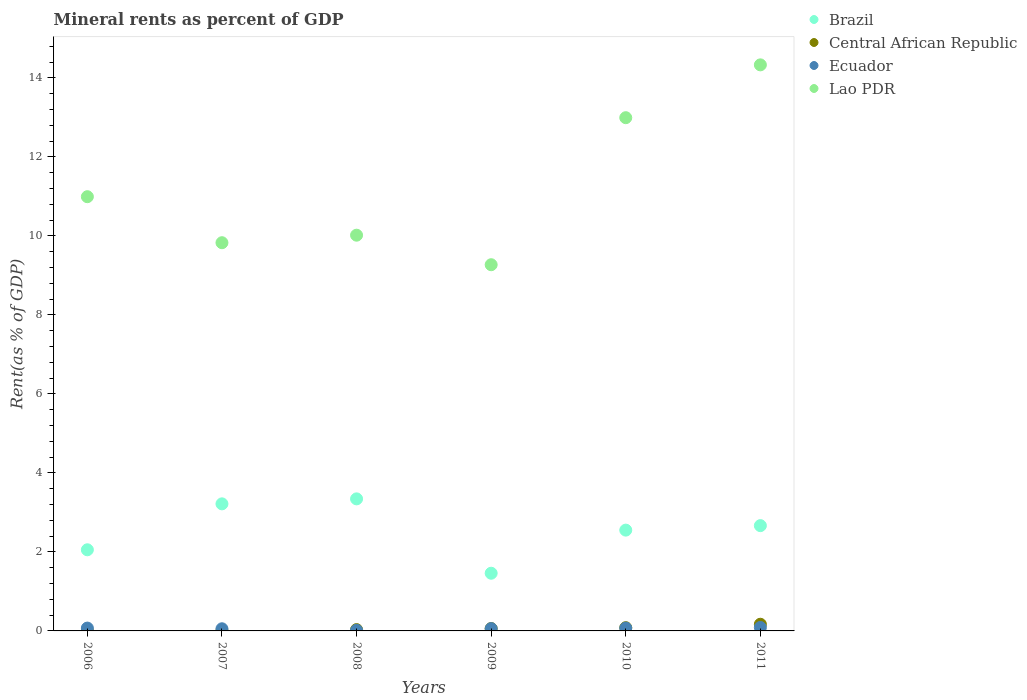What is the mineral rent in Lao PDR in 2010?
Offer a terse response. 12.99. Across all years, what is the maximum mineral rent in Central African Republic?
Offer a very short reply. 0.17. Across all years, what is the minimum mineral rent in Central African Republic?
Provide a short and direct response. 0.01. What is the total mineral rent in Ecuador in the graph?
Make the answer very short. 0.36. What is the difference between the mineral rent in Central African Republic in 2009 and that in 2011?
Provide a succinct answer. -0.11. What is the difference between the mineral rent in Central African Republic in 2006 and the mineral rent in Brazil in 2008?
Ensure brevity in your answer.  -3.34. What is the average mineral rent in Central African Republic per year?
Your answer should be very brief. 0.06. In the year 2011, what is the difference between the mineral rent in Lao PDR and mineral rent in Central African Republic?
Your answer should be compact. 14.16. In how many years, is the mineral rent in Ecuador greater than 12 %?
Ensure brevity in your answer.  0. What is the ratio of the mineral rent in Ecuador in 2007 to that in 2009?
Your response must be concise. 0.93. What is the difference between the highest and the second highest mineral rent in Ecuador?
Make the answer very short. 0.02. What is the difference between the highest and the lowest mineral rent in Central African Republic?
Provide a succinct answer. 0.16. Is the sum of the mineral rent in Central African Republic in 2007 and 2011 greater than the maximum mineral rent in Ecuador across all years?
Make the answer very short. Yes. Is it the case that in every year, the sum of the mineral rent in Ecuador and mineral rent in Central African Republic  is greater than the sum of mineral rent in Lao PDR and mineral rent in Brazil?
Your answer should be compact. No. Are the values on the major ticks of Y-axis written in scientific E-notation?
Offer a terse response. No. Does the graph contain any zero values?
Offer a terse response. No. Does the graph contain grids?
Your response must be concise. No. Where does the legend appear in the graph?
Ensure brevity in your answer.  Top right. What is the title of the graph?
Ensure brevity in your answer.  Mineral rents as percent of GDP. Does "Vietnam" appear as one of the legend labels in the graph?
Offer a terse response. No. What is the label or title of the X-axis?
Give a very brief answer. Years. What is the label or title of the Y-axis?
Provide a succinct answer. Rent(as % of GDP). What is the Rent(as % of GDP) in Brazil in 2006?
Make the answer very short. 2.05. What is the Rent(as % of GDP) of Central African Republic in 2006?
Give a very brief answer. 0.01. What is the Rent(as % of GDP) in Ecuador in 2006?
Keep it short and to the point. 0.07. What is the Rent(as % of GDP) of Lao PDR in 2006?
Keep it short and to the point. 10.99. What is the Rent(as % of GDP) of Brazil in 2007?
Provide a short and direct response. 3.22. What is the Rent(as % of GDP) of Central African Republic in 2007?
Your answer should be compact. 0.01. What is the Rent(as % of GDP) of Ecuador in 2007?
Your answer should be compact. 0.05. What is the Rent(as % of GDP) in Lao PDR in 2007?
Give a very brief answer. 9.83. What is the Rent(as % of GDP) in Brazil in 2008?
Keep it short and to the point. 3.34. What is the Rent(as % of GDP) of Central African Republic in 2008?
Your answer should be very brief. 0.03. What is the Rent(as % of GDP) of Ecuador in 2008?
Your answer should be compact. 0.02. What is the Rent(as % of GDP) of Lao PDR in 2008?
Your response must be concise. 10.02. What is the Rent(as % of GDP) in Brazil in 2009?
Keep it short and to the point. 1.46. What is the Rent(as % of GDP) in Central African Republic in 2009?
Provide a short and direct response. 0.06. What is the Rent(as % of GDP) in Ecuador in 2009?
Make the answer very short. 0.06. What is the Rent(as % of GDP) in Lao PDR in 2009?
Ensure brevity in your answer.  9.27. What is the Rent(as % of GDP) in Brazil in 2010?
Provide a short and direct response. 2.55. What is the Rent(as % of GDP) of Central African Republic in 2010?
Your response must be concise. 0.08. What is the Rent(as % of GDP) in Ecuador in 2010?
Provide a short and direct response. 0.07. What is the Rent(as % of GDP) of Lao PDR in 2010?
Give a very brief answer. 12.99. What is the Rent(as % of GDP) in Brazil in 2011?
Offer a very short reply. 2.66. What is the Rent(as % of GDP) of Central African Republic in 2011?
Your response must be concise. 0.17. What is the Rent(as % of GDP) of Ecuador in 2011?
Your answer should be compact. 0.09. What is the Rent(as % of GDP) of Lao PDR in 2011?
Your response must be concise. 14.33. Across all years, what is the maximum Rent(as % of GDP) of Brazil?
Your response must be concise. 3.34. Across all years, what is the maximum Rent(as % of GDP) of Central African Republic?
Your response must be concise. 0.17. Across all years, what is the maximum Rent(as % of GDP) in Ecuador?
Your answer should be compact. 0.09. Across all years, what is the maximum Rent(as % of GDP) in Lao PDR?
Provide a succinct answer. 14.33. Across all years, what is the minimum Rent(as % of GDP) in Brazil?
Offer a very short reply. 1.46. Across all years, what is the minimum Rent(as % of GDP) of Central African Republic?
Keep it short and to the point. 0.01. Across all years, what is the minimum Rent(as % of GDP) of Ecuador?
Your answer should be very brief. 0.02. Across all years, what is the minimum Rent(as % of GDP) of Lao PDR?
Ensure brevity in your answer.  9.27. What is the total Rent(as % of GDP) in Brazil in the graph?
Make the answer very short. 15.29. What is the total Rent(as % of GDP) in Central African Republic in the graph?
Make the answer very short. 0.36. What is the total Rent(as % of GDP) of Ecuador in the graph?
Your response must be concise. 0.36. What is the total Rent(as % of GDP) of Lao PDR in the graph?
Your answer should be compact. 67.42. What is the difference between the Rent(as % of GDP) in Brazil in 2006 and that in 2007?
Make the answer very short. -1.16. What is the difference between the Rent(as % of GDP) of Central African Republic in 2006 and that in 2007?
Make the answer very short. -0. What is the difference between the Rent(as % of GDP) in Ecuador in 2006 and that in 2007?
Your answer should be compact. 0.02. What is the difference between the Rent(as % of GDP) of Lao PDR in 2006 and that in 2007?
Give a very brief answer. 1.16. What is the difference between the Rent(as % of GDP) in Brazil in 2006 and that in 2008?
Provide a short and direct response. -1.29. What is the difference between the Rent(as % of GDP) of Central African Republic in 2006 and that in 2008?
Offer a terse response. -0.03. What is the difference between the Rent(as % of GDP) of Ecuador in 2006 and that in 2008?
Make the answer very short. 0.05. What is the difference between the Rent(as % of GDP) of Lao PDR in 2006 and that in 2008?
Your response must be concise. 0.97. What is the difference between the Rent(as % of GDP) in Brazil in 2006 and that in 2009?
Give a very brief answer. 0.59. What is the difference between the Rent(as % of GDP) of Central African Republic in 2006 and that in 2009?
Ensure brevity in your answer.  -0.05. What is the difference between the Rent(as % of GDP) in Ecuador in 2006 and that in 2009?
Your response must be concise. 0.01. What is the difference between the Rent(as % of GDP) of Lao PDR in 2006 and that in 2009?
Offer a terse response. 1.72. What is the difference between the Rent(as % of GDP) of Brazil in 2006 and that in 2010?
Give a very brief answer. -0.5. What is the difference between the Rent(as % of GDP) in Central African Republic in 2006 and that in 2010?
Provide a succinct answer. -0.08. What is the difference between the Rent(as % of GDP) in Ecuador in 2006 and that in 2010?
Your response must be concise. -0. What is the difference between the Rent(as % of GDP) of Lao PDR in 2006 and that in 2010?
Ensure brevity in your answer.  -2. What is the difference between the Rent(as % of GDP) in Brazil in 2006 and that in 2011?
Make the answer very short. -0.61. What is the difference between the Rent(as % of GDP) of Central African Republic in 2006 and that in 2011?
Offer a very short reply. -0.16. What is the difference between the Rent(as % of GDP) of Ecuador in 2006 and that in 2011?
Your response must be concise. -0.02. What is the difference between the Rent(as % of GDP) of Lao PDR in 2006 and that in 2011?
Provide a short and direct response. -3.34. What is the difference between the Rent(as % of GDP) in Brazil in 2007 and that in 2008?
Your response must be concise. -0.13. What is the difference between the Rent(as % of GDP) in Central African Republic in 2007 and that in 2008?
Provide a short and direct response. -0.03. What is the difference between the Rent(as % of GDP) in Ecuador in 2007 and that in 2008?
Give a very brief answer. 0.04. What is the difference between the Rent(as % of GDP) in Lao PDR in 2007 and that in 2008?
Keep it short and to the point. -0.19. What is the difference between the Rent(as % of GDP) in Brazil in 2007 and that in 2009?
Your answer should be very brief. 1.76. What is the difference between the Rent(as % of GDP) of Central African Republic in 2007 and that in 2009?
Your response must be concise. -0.05. What is the difference between the Rent(as % of GDP) of Ecuador in 2007 and that in 2009?
Keep it short and to the point. -0. What is the difference between the Rent(as % of GDP) of Lao PDR in 2007 and that in 2009?
Your response must be concise. 0.56. What is the difference between the Rent(as % of GDP) of Brazil in 2007 and that in 2010?
Your response must be concise. 0.67. What is the difference between the Rent(as % of GDP) of Central African Republic in 2007 and that in 2010?
Provide a short and direct response. -0.08. What is the difference between the Rent(as % of GDP) in Ecuador in 2007 and that in 2010?
Ensure brevity in your answer.  -0.02. What is the difference between the Rent(as % of GDP) in Lao PDR in 2007 and that in 2010?
Your response must be concise. -3.16. What is the difference between the Rent(as % of GDP) of Brazil in 2007 and that in 2011?
Your answer should be compact. 0.55. What is the difference between the Rent(as % of GDP) of Central African Republic in 2007 and that in 2011?
Your response must be concise. -0.16. What is the difference between the Rent(as % of GDP) of Ecuador in 2007 and that in 2011?
Ensure brevity in your answer.  -0.03. What is the difference between the Rent(as % of GDP) in Lao PDR in 2007 and that in 2011?
Provide a short and direct response. -4.5. What is the difference between the Rent(as % of GDP) in Brazil in 2008 and that in 2009?
Keep it short and to the point. 1.88. What is the difference between the Rent(as % of GDP) of Central African Republic in 2008 and that in 2009?
Ensure brevity in your answer.  -0.03. What is the difference between the Rent(as % of GDP) of Ecuador in 2008 and that in 2009?
Provide a succinct answer. -0.04. What is the difference between the Rent(as % of GDP) in Lao PDR in 2008 and that in 2009?
Provide a succinct answer. 0.75. What is the difference between the Rent(as % of GDP) in Brazil in 2008 and that in 2010?
Offer a very short reply. 0.79. What is the difference between the Rent(as % of GDP) in Central African Republic in 2008 and that in 2010?
Your answer should be very brief. -0.05. What is the difference between the Rent(as % of GDP) of Ecuador in 2008 and that in 2010?
Make the answer very short. -0.05. What is the difference between the Rent(as % of GDP) of Lao PDR in 2008 and that in 2010?
Provide a succinct answer. -2.97. What is the difference between the Rent(as % of GDP) of Brazil in 2008 and that in 2011?
Offer a terse response. 0.68. What is the difference between the Rent(as % of GDP) in Central African Republic in 2008 and that in 2011?
Offer a very short reply. -0.14. What is the difference between the Rent(as % of GDP) of Ecuador in 2008 and that in 2011?
Keep it short and to the point. -0.07. What is the difference between the Rent(as % of GDP) in Lao PDR in 2008 and that in 2011?
Give a very brief answer. -4.31. What is the difference between the Rent(as % of GDP) in Brazil in 2009 and that in 2010?
Your answer should be compact. -1.09. What is the difference between the Rent(as % of GDP) of Central African Republic in 2009 and that in 2010?
Offer a terse response. -0.02. What is the difference between the Rent(as % of GDP) in Ecuador in 2009 and that in 2010?
Keep it short and to the point. -0.01. What is the difference between the Rent(as % of GDP) in Lao PDR in 2009 and that in 2010?
Provide a succinct answer. -3.72. What is the difference between the Rent(as % of GDP) of Brazil in 2009 and that in 2011?
Ensure brevity in your answer.  -1.2. What is the difference between the Rent(as % of GDP) in Central African Republic in 2009 and that in 2011?
Offer a terse response. -0.11. What is the difference between the Rent(as % of GDP) in Ecuador in 2009 and that in 2011?
Your answer should be compact. -0.03. What is the difference between the Rent(as % of GDP) of Lao PDR in 2009 and that in 2011?
Your response must be concise. -5.06. What is the difference between the Rent(as % of GDP) in Brazil in 2010 and that in 2011?
Your response must be concise. -0.11. What is the difference between the Rent(as % of GDP) in Central African Republic in 2010 and that in 2011?
Provide a succinct answer. -0.09. What is the difference between the Rent(as % of GDP) in Ecuador in 2010 and that in 2011?
Your answer should be compact. -0.02. What is the difference between the Rent(as % of GDP) in Lao PDR in 2010 and that in 2011?
Give a very brief answer. -1.34. What is the difference between the Rent(as % of GDP) in Brazil in 2006 and the Rent(as % of GDP) in Central African Republic in 2007?
Keep it short and to the point. 2.05. What is the difference between the Rent(as % of GDP) of Brazil in 2006 and the Rent(as % of GDP) of Ecuador in 2007?
Offer a very short reply. 2. What is the difference between the Rent(as % of GDP) in Brazil in 2006 and the Rent(as % of GDP) in Lao PDR in 2007?
Offer a very short reply. -7.77. What is the difference between the Rent(as % of GDP) in Central African Republic in 2006 and the Rent(as % of GDP) in Ecuador in 2007?
Offer a terse response. -0.05. What is the difference between the Rent(as % of GDP) in Central African Republic in 2006 and the Rent(as % of GDP) in Lao PDR in 2007?
Your answer should be very brief. -9.82. What is the difference between the Rent(as % of GDP) in Ecuador in 2006 and the Rent(as % of GDP) in Lao PDR in 2007?
Offer a very short reply. -9.75. What is the difference between the Rent(as % of GDP) of Brazil in 2006 and the Rent(as % of GDP) of Central African Republic in 2008?
Make the answer very short. 2.02. What is the difference between the Rent(as % of GDP) in Brazil in 2006 and the Rent(as % of GDP) in Ecuador in 2008?
Keep it short and to the point. 2.04. What is the difference between the Rent(as % of GDP) of Brazil in 2006 and the Rent(as % of GDP) of Lao PDR in 2008?
Ensure brevity in your answer.  -7.96. What is the difference between the Rent(as % of GDP) of Central African Republic in 2006 and the Rent(as % of GDP) of Ecuador in 2008?
Your answer should be compact. -0.01. What is the difference between the Rent(as % of GDP) of Central African Republic in 2006 and the Rent(as % of GDP) of Lao PDR in 2008?
Provide a short and direct response. -10.01. What is the difference between the Rent(as % of GDP) in Ecuador in 2006 and the Rent(as % of GDP) in Lao PDR in 2008?
Make the answer very short. -9.94. What is the difference between the Rent(as % of GDP) in Brazil in 2006 and the Rent(as % of GDP) in Central African Republic in 2009?
Ensure brevity in your answer.  1.99. What is the difference between the Rent(as % of GDP) in Brazil in 2006 and the Rent(as % of GDP) in Ecuador in 2009?
Your answer should be very brief. 2. What is the difference between the Rent(as % of GDP) in Brazil in 2006 and the Rent(as % of GDP) in Lao PDR in 2009?
Provide a succinct answer. -7.22. What is the difference between the Rent(as % of GDP) in Central African Republic in 2006 and the Rent(as % of GDP) in Ecuador in 2009?
Give a very brief answer. -0.05. What is the difference between the Rent(as % of GDP) of Central African Republic in 2006 and the Rent(as % of GDP) of Lao PDR in 2009?
Your response must be concise. -9.26. What is the difference between the Rent(as % of GDP) of Ecuador in 2006 and the Rent(as % of GDP) of Lao PDR in 2009?
Offer a very short reply. -9.2. What is the difference between the Rent(as % of GDP) in Brazil in 2006 and the Rent(as % of GDP) in Central African Republic in 2010?
Provide a succinct answer. 1.97. What is the difference between the Rent(as % of GDP) in Brazil in 2006 and the Rent(as % of GDP) in Ecuador in 2010?
Offer a very short reply. 1.98. What is the difference between the Rent(as % of GDP) of Brazil in 2006 and the Rent(as % of GDP) of Lao PDR in 2010?
Your answer should be very brief. -10.94. What is the difference between the Rent(as % of GDP) in Central African Republic in 2006 and the Rent(as % of GDP) in Ecuador in 2010?
Make the answer very short. -0.07. What is the difference between the Rent(as % of GDP) of Central African Republic in 2006 and the Rent(as % of GDP) of Lao PDR in 2010?
Your answer should be very brief. -12.99. What is the difference between the Rent(as % of GDP) of Ecuador in 2006 and the Rent(as % of GDP) of Lao PDR in 2010?
Offer a very short reply. -12.92. What is the difference between the Rent(as % of GDP) of Brazil in 2006 and the Rent(as % of GDP) of Central African Republic in 2011?
Ensure brevity in your answer.  1.88. What is the difference between the Rent(as % of GDP) in Brazil in 2006 and the Rent(as % of GDP) in Ecuador in 2011?
Provide a succinct answer. 1.97. What is the difference between the Rent(as % of GDP) in Brazil in 2006 and the Rent(as % of GDP) in Lao PDR in 2011?
Your answer should be compact. -12.27. What is the difference between the Rent(as % of GDP) of Central African Republic in 2006 and the Rent(as % of GDP) of Ecuador in 2011?
Offer a terse response. -0.08. What is the difference between the Rent(as % of GDP) of Central African Republic in 2006 and the Rent(as % of GDP) of Lao PDR in 2011?
Provide a succinct answer. -14.32. What is the difference between the Rent(as % of GDP) in Ecuador in 2006 and the Rent(as % of GDP) in Lao PDR in 2011?
Make the answer very short. -14.26. What is the difference between the Rent(as % of GDP) in Brazil in 2007 and the Rent(as % of GDP) in Central African Republic in 2008?
Give a very brief answer. 3.18. What is the difference between the Rent(as % of GDP) in Brazil in 2007 and the Rent(as % of GDP) in Ecuador in 2008?
Ensure brevity in your answer.  3.2. What is the difference between the Rent(as % of GDP) in Brazil in 2007 and the Rent(as % of GDP) in Lao PDR in 2008?
Make the answer very short. -6.8. What is the difference between the Rent(as % of GDP) of Central African Republic in 2007 and the Rent(as % of GDP) of Ecuador in 2008?
Ensure brevity in your answer.  -0.01. What is the difference between the Rent(as % of GDP) in Central African Republic in 2007 and the Rent(as % of GDP) in Lao PDR in 2008?
Give a very brief answer. -10.01. What is the difference between the Rent(as % of GDP) of Ecuador in 2007 and the Rent(as % of GDP) of Lao PDR in 2008?
Ensure brevity in your answer.  -9.96. What is the difference between the Rent(as % of GDP) of Brazil in 2007 and the Rent(as % of GDP) of Central African Republic in 2009?
Make the answer very short. 3.16. What is the difference between the Rent(as % of GDP) of Brazil in 2007 and the Rent(as % of GDP) of Ecuador in 2009?
Offer a very short reply. 3.16. What is the difference between the Rent(as % of GDP) of Brazil in 2007 and the Rent(as % of GDP) of Lao PDR in 2009?
Make the answer very short. -6.05. What is the difference between the Rent(as % of GDP) in Central African Republic in 2007 and the Rent(as % of GDP) in Ecuador in 2009?
Make the answer very short. -0.05. What is the difference between the Rent(as % of GDP) in Central African Republic in 2007 and the Rent(as % of GDP) in Lao PDR in 2009?
Your answer should be very brief. -9.26. What is the difference between the Rent(as % of GDP) of Ecuador in 2007 and the Rent(as % of GDP) of Lao PDR in 2009?
Ensure brevity in your answer.  -9.21. What is the difference between the Rent(as % of GDP) in Brazil in 2007 and the Rent(as % of GDP) in Central African Republic in 2010?
Provide a short and direct response. 3.13. What is the difference between the Rent(as % of GDP) of Brazil in 2007 and the Rent(as % of GDP) of Ecuador in 2010?
Your answer should be very brief. 3.14. What is the difference between the Rent(as % of GDP) in Brazil in 2007 and the Rent(as % of GDP) in Lao PDR in 2010?
Your answer should be very brief. -9.77. What is the difference between the Rent(as % of GDP) of Central African Republic in 2007 and the Rent(as % of GDP) of Ecuador in 2010?
Your answer should be compact. -0.07. What is the difference between the Rent(as % of GDP) of Central African Republic in 2007 and the Rent(as % of GDP) of Lao PDR in 2010?
Keep it short and to the point. -12.98. What is the difference between the Rent(as % of GDP) of Ecuador in 2007 and the Rent(as % of GDP) of Lao PDR in 2010?
Ensure brevity in your answer.  -12.94. What is the difference between the Rent(as % of GDP) of Brazil in 2007 and the Rent(as % of GDP) of Central African Republic in 2011?
Provide a short and direct response. 3.05. What is the difference between the Rent(as % of GDP) of Brazil in 2007 and the Rent(as % of GDP) of Ecuador in 2011?
Your answer should be very brief. 3.13. What is the difference between the Rent(as % of GDP) of Brazil in 2007 and the Rent(as % of GDP) of Lao PDR in 2011?
Make the answer very short. -11.11. What is the difference between the Rent(as % of GDP) of Central African Republic in 2007 and the Rent(as % of GDP) of Ecuador in 2011?
Offer a very short reply. -0.08. What is the difference between the Rent(as % of GDP) in Central African Republic in 2007 and the Rent(as % of GDP) in Lao PDR in 2011?
Your answer should be compact. -14.32. What is the difference between the Rent(as % of GDP) in Ecuador in 2007 and the Rent(as % of GDP) in Lao PDR in 2011?
Offer a very short reply. -14.27. What is the difference between the Rent(as % of GDP) in Brazil in 2008 and the Rent(as % of GDP) in Central African Republic in 2009?
Ensure brevity in your answer.  3.28. What is the difference between the Rent(as % of GDP) of Brazil in 2008 and the Rent(as % of GDP) of Ecuador in 2009?
Make the answer very short. 3.28. What is the difference between the Rent(as % of GDP) of Brazil in 2008 and the Rent(as % of GDP) of Lao PDR in 2009?
Your answer should be very brief. -5.93. What is the difference between the Rent(as % of GDP) of Central African Republic in 2008 and the Rent(as % of GDP) of Ecuador in 2009?
Your answer should be compact. -0.02. What is the difference between the Rent(as % of GDP) of Central African Republic in 2008 and the Rent(as % of GDP) of Lao PDR in 2009?
Your answer should be very brief. -9.24. What is the difference between the Rent(as % of GDP) of Ecuador in 2008 and the Rent(as % of GDP) of Lao PDR in 2009?
Your answer should be compact. -9.25. What is the difference between the Rent(as % of GDP) of Brazil in 2008 and the Rent(as % of GDP) of Central African Republic in 2010?
Offer a terse response. 3.26. What is the difference between the Rent(as % of GDP) in Brazil in 2008 and the Rent(as % of GDP) in Ecuador in 2010?
Keep it short and to the point. 3.27. What is the difference between the Rent(as % of GDP) of Brazil in 2008 and the Rent(as % of GDP) of Lao PDR in 2010?
Your answer should be very brief. -9.65. What is the difference between the Rent(as % of GDP) of Central African Republic in 2008 and the Rent(as % of GDP) of Ecuador in 2010?
Provide a short and direct response. -0.04. What is the difference between the Rent(as % of GDP) of Central African Republic in 2008 and the Rent(as % of GDP) of Lao PDR in 2010?
Provide a succinct answer. -12.96. What is the difference between the Rent(as % of GDP) of Ecuador in 2008 and the Rent(as % of GDP) of Lao PDR in 2010?
Keep it short and to the point. -12.97. What is the difference between the Rent(as % of GDP) of Brazil in 2008 and the Rent(as % of GDP) of Central African Republic in 2011?
Your answer should be very brief. 3.17. What is the difference between the Rent(as % of GDP) of Brazil in 2008 and the Rent(as % of GDP) of Ecuador in 2011?
Keep it short and to the point. 3.25. What is the difference between the Rent(as % of GDP) of Brazil in 2008 and the Rent(as % of GDP) of Lao PDR in 2011?
Keep it short and to the point. -10.99. What is the difference between the Rent(as % of GDP) in Central African Republic in 2008 and the Rent(as % of GDP) in Ecuador in 2011?
Offer a very short reply. -0.05. What is the difference between the Rent(as % of GDP) of Central African Republic in 2008 and the Rent(as % of GDP) of Lao PDR in 2011?
Your answer should be very brief. -14.29. What is the difference between the Rent(as % of GDP) in Ecuador in 2008 and the Rent(as % of GDP) in Lao PDR in 2011?
Offer a terse response. -14.31. What is the difference between the Rent(as % of GDP) in Brazil in 2009 and the Rent(as % of GDP) in Central African Republic in 2010?
Keep it short and to the point. 1.38. What is the difference between the Rent(as % of GDP) in Brazil in 2009 and the Rent(as % of GDP) in Ecuador in 2010?
Your response must be concise. 1.39. What is the difference between the Rent(as % of GDP) of Brazil in 2009 and the Rent(as % of GDP) of Lao PDR in 2010?
Make the answer very short. -11.53. What is the difference between the Rent(as % of GDP) in Central African Republic in 2009 and the Rent(as % of GDP) in Ecuador in 2010?
Your answer should be very brief. -0.01. What is the difference between the Rent(as % of GDP) in Central African Republic in 2009 and the Rent(as % of GDP) in Lao PDR in 2010?
Ensure brevity in your answer.  -12.93. What is the difference between the Rent(as % of GDP) of Ecuador in 2009 and the Rent(as % of GDP) of Lao PDR in 2010?
Offer a terse response. -12.93. What is the difference between the Rent(as % of GDP) of Brazil in 2009 and the Rent(as % of GDP) of Central African Republic in 2011?
Ensure brevity in your answer.  1.29. What is the difference between the Rent(as % of GDP) of Brazil in 2009 and the Rent(as % of GDP) of Ecuador in 2011?
Give a very brief answer. 1.37. What is the difference between the Rent(as % of GDP) in Brazil in 2009 and the Rent(as % of GDP) in Lao PDR in 2011?
Your answer should be very brief. -12.87. What is the difference between the Rent(as % of GDP) in Central African Republic in 2009 and the Rent(as % of GDP) in Ecuador in 2011?
Your answer should be compact. -0.03. What is the difference between the Rent(as % of GDP) in Central African Republic in 2009 and the Rent(as % of GDP) in Lao PDR in 2011?
Keep it short and to the point. -14.27. What is the difference between the Rent(as % of GDP) in Ecuador in 2009 and the Rent(as % of GDP) in Lao PDR in 2011?
Provide a short and direct response. -14.27. What is the difference between the Rent(as % of GDP) in Brazil in 2010 and the Rent(as % of GDP) in Central African Republic in 2011?
Your answer should be very brief. 2.38. What is the difference between the Rent(as % of GDP) in Brazil in 2010 and the Rent(as % of GDP) in Ecuador in 2011?
Make the answer very short. 2.46. What is the difference between the Rent(as % of GDP) in Brazil in 2010 and the Rent(as % of GDP) in Lao PDR in 2011?
Ensure brevity in your answer.  -11.78. What is the difference between the Rent(as % of GDP) of Central African Republic in 2010 and the Rent(as % of GDP) of Ecuador in 2011?
Provide a succinct answer. -0.01. What is the difference between the Rent(as % of GDP) in Central African Republic in 2010 and the Rent(as % of GDP) in Lao PDR in 2011?
Provide a short and direct response. -14.25. What is the difference between the Rent(as % of GDP) of Ecuador in 2010 and the Rent(as % of GDP) of Lao PDR in 2011?
Keep it short and to the point. -14.26. What is the average Rent(as % of GDP) in Brazil per year?
Keep it short and to the point. 2.55. What is the average Rent(as % of GDP) of Central African Republic per year?
Provide a short and direct response. 0.06. What is the average Rent(as % of GDP) of Ecuador per year?
Your response must be concise. 0.06. What is the average Rent(as % of GDP) of Lao PDR per year?
Keep it short and to the point. 11.24. In the year 2006, what is the difference between the Rent(as % of GDP) of Brazil and Rent(as % of GDP) of Central African Republic?
Give a very brief answer. 2.05. In the year 2006, what is the difference between the Rent(as % of GDP) of Brazil and Rent(as % of GDP) of Ecuador?
Your answer should be very brief. 1.98. In the year 2006, what is the difference between the Rent(as % of GDP) in Brazil and Rent(as % of GDP) in Lao PDR?
Give a very brief answer. -8.94. In the year 2006, what is the difference between the Rent(as % of GDP) of Central African Republic and Rent(as % of GDP) of Ecuador?
Make the answer very short. -0.07. In the year 2006, what is the difference between the Rent(as % of GDP) of Central African Republic and Rent(as % of GDP) of Lao PDR?
Provide a short and direct response. -10.99. In the year 2006, what is the difference between the Rent(as % of GDP) in Ecuador and Rent(as % of GDP) in Lao PDR?
Ensure brevity in your answer.  -10.92. In the year 2007, what is the difference between the Rent(as % of GDP) of Brazil and Rent(as % of GDP) of Central African Republic?
Make the answer very short. 3.21. In the year 2007, what is the difference between the Rent(as % of GDP) of Brazil and Rent(as % of GDP) of Ecuador?
Your response must be concise. 3.16. In the year 2007, what is the difference between the Rent(as % of GDP) of Brazil and Rent(as % of GDP) of Lao PDR?
Your answer should be very brief. -6.61. In the year 2007, what is the difference between the Rent(as % of GDP) in Central African Republic and Rent(as % of GDP) in Ecuador?
Offer a very short reply. -0.05. In the year 2007, what is the difference between the Rent(as % of GDP) in Central African Republic and Rent(as % of GDP) in Lao PDR?
Your answer should be very brief. -9.82. In the year 2007, what is the difference between the Rent(as % of GDP) in Ecuador and Rent(as % of GDP) in Lao PDR?
Offer a terse response. -9.77. In the year 2008, what is the difference between the Rent(as % of GDP) of Brazil and Rent(as % of GDP) of Central African Republic?
Provide a short and direct response. 3.31. In the year 2008, what is the difference between the Rent(as % of GDP) in Brazil and Rent(as % of GDP) in Ecuador?
Give a very brief answer. 3.33. In the year 2008, what is the difference between the Rent(as % of GDP) of Brazil and Rent(as % of GDP) of Lao PDR?
Keep it short and to the point. -6.67. In the year 2008, what is the difference between the Rent(as % of GDP) of Central African Republic and Rent(as % of GDP) of Ecuador?
Offer a terse response. 0.02. In the year 2008, what is the difference between the Rent(as % of GDP) of Central African Republic and Rent(as % of GDP) of Lao PDR?
Your answer should be very brief. -9.98. In the year 2008, what is the difference between the Rent(as % of GDP) of Ecuador and Rent(as % of GDP) of Lao PDR?
Keep it short and to the point. -10. In the year 2009, what is the difference between the Rent(as % of GDP) of Brazil and Rent(as % of GDP) of Central African Republic?
Provide a short and direct response. 1.4. In the year 2009, what is the difference between the Rent(as % of GDP) of Brazil and Rent(as % of GDP) of Ecuador?
Provide a succinct answer. 1.4. In the year 2009, what is the difference between the Rent(as % of GDP) in Brazil and Rent(as % of GDP) in Lao PDR?
Keep it short and to the point. -7.81. In the year 2009, what is the difference between the Rent(as % of GDP) of Central African Republic and Rent(as % of GDP) of Ecuador?
Your response must be concise. 0. In the year 2009, what is the difference between the Rent(as % of GDP) in Central African Republic and Rent(as % of GDP) in Lao PDR?
Keep it short and to the point. -9.21. In the year 2009, what is the difference between the Rent(as % of GDP) of Ecuador and Rent(as % of GDP) of Lao PDR?
Your answer should be compact. -9.21. In the year 2010, what is the difference between the Rent(as % of GDP) in Brazil and Rent(as % of GDP) in Central African Republic?
Your answer should be compact. 2.47. In the year 2010, what is the difference between the Rent(as % of GDP) of Brazil and Rent(as % of GDP) of Ecuador?
Offer a very short reply. 2.48. In the year 2010, what is the difference between the Rent(as % of GDP) of Brazil and Rent(as % of GDP) of Lao PDR?
Your response must be concise. -10.44. In the year 2010, what is the difference between the Rent(as % of GDP) of Central African Republic and Rent(as % of GDP) of Ecuador?
Ensure brevity in your answer.  0.01. In the year 2010, what is the difference between the Rent(as % of GDP) of Central African Republic and Rent(as % of GDP) of Lao PDR?
Give a very brief answer. -12.91. In the year 2010, what is the difference between the Rent(as % of GDP) of Ecuador and Rent(as % of GDP) of Lao PDR?
Offer a very short reply. -12.92. In the year 2011, what is the difference between the Rent(as % of GDP) in Brazil and Rent(as % of GDP) in Central African Republic?
Your answer should be compact. 2.5. In the year 2011, what is the difference between the Rent(as % of GDP) of Brazil and Rent(as % of GDP) of Ecuador?
Give a very brief answer. 2.58. In the year 2011, what is the difference between the Rent(as % of GDP) of Brazil and Rent(as % of GDP) of Lao PDR?
Keep it short and to the point. -11.66. In the year 2011, what is the difference between the Rent(as % of GDP) in Central African Republic and Rent(as % of GDP) in Ecuador?
Make the answer very short. 0.08. In the year 2011, what is the difference between the Rent(as % of GDP) in Central African Republic and Rent(as % of GDP) in Lao PDR?
Offer a terse response. -14.16. In the year 2011, what is the difference between the Rent(as % of GDP) in Ecuador and Rent(as % of GDP) in Lao PDR?
Offer a terse response. -14.24. What is the ratio of the Rent(as % of GDP) of Brazil in 2006 to that in 2007?
Provide a succinct answer. 0.64. What is the ratio of the Rent(as % of GDP) in Central African Republic in 2006 to that in 2007?
Keep it short and to the point. 0.91. What is the ratio of the Rent(as % of GDP) in Ecuador in 2006 to that in 2007?
Offer a very short reply. 1.32. What is the ratio of the Rent(as % of GDP) in Lao PDR in 2006 to that in 2007?
Make the answer very short. 1.12. What is the ratio of the Rent(as % of GDP) of Brazil in 2006 to that in 2008?
Your answer should be very brief. 0.61. What is the ratio of the Rent(as % of GDP) of Central African Republic in 2006 to that in 2008?
Provide a succinct answer. 0.17. What is the ratio of the Rent(as % of GDP) of Ecuador in 2006 to that in 2008?
Make the answer very short. 4.19. What is the ratio of the Rent(as % of GDP) in Lao PDR in 2006 to that in 2008?
Your response must be concise. 1.1. What is the ratio of the Rent(as % of GDP) of Brazil in 2006 to that in 2009?
Make the answer very short. 1.41. What is the ratio of the Rent(as % of GDP) of Central African Republic in 2006 to that in 2009?
Give a very brief answer. 0.1. What is the ratio of the Rent(as % of GDP) in Ecuador in 2006 to that in 2009?
Your response must be concise. 1.23. What is the ratio of the Rent(as % of GDP) of Lao PDR in 2006 to that in 2009?
Your answer should be compact. 1.19. What is the ratio of the Rent(as % of GDP) of Brazil in 2006 to that in 2010?
Offer a terse response. 0.8. What is the ratio of the Rent(as % of GDP) in Central African Republic in 2006 to that in 2010?
Give a very brief answer. 0.07. What is the ratio of the Rent(as % of GDP) of Ecuador in 2006 to that in 2010?
Your response must be concise. 1. What is the ratio of the Rent(as % of GDP) of Lao PDR in 2006 to that in 2010?
Provide a succinct answer. 0.85. What is the ratio of the Rent(as % of GDP) of Brazil in 2006 to that in 2011?
Give a very brief answer. 0.77. What is the ratio of the Rent(as % of GDP) of Central African Republic in 2006 to that in 2011?
Keep it short and to the point. 0.03. What is the ratio of the Rent(as % of GDP) in Ecuador in 2006 to that in 2011?
Offer a very short reply. 0.82. What is the ratio of the Rent(as % of GDP) of Lao PDR in 2006 to that in 2011?
Your answer should be very brief. 0.77. What is the ratio of the Rent(as % of GDP) in Brazil in 2007 to that in 2008?
Offer a very short reply. 0.96. What is the ratio of the Rent(as % of GDP) of Central African Republic in 2007 to that in 2008?
Offer a terse response. 0.19. What is the ratio of the Rent(as % of GDP) in Ecuador in 2007 to that in 2008?
Offer a terse response. 3.16. What is the ratio of the Rent(as % of GDP) of Lao PDR in 2007 to that in 2008?
Keep it short and to the point. 0.98. What is the ratio of the Rent(as % of GDP) of Brazil in 2007 to that in 2009?
Make the answer very short. 2.2. What is the ratio of the Rent(as % of GDP) in Central African Republic in 2007 to that in 2009?
Your response must be concise. 0.11. What is the ratio of the Rent(as % of GDP) of Ecuador in 2007 to that in 2009?
Give a very brief answer. 0.93. What is the ratio of the Rent(as % of GDP) of Lao PDR in 2007 to that in 2009?
Make the answer very short. 1.06. What is the ratio of the Rent(as % of GDP) in Brazil in 2007 to that in 2010?
Make the answer very short. 1.26. What is the ratio of the Rent(as % of GDP) of Central African Republic in 2007 to that in 2010?
Your response must be concise. 0.08. What is the ratio of the Rent(as % of GDP) in Ecuador in 2007 to that in 2010?
Your answer should be compact. 0.75. What is the ratio of the Rent(as % of GDP) of Lao PDR in 2007 to that in 2010?
Offer a terse response. 0.76. What is the ratio of the Rent(as % of GDP) in Brazil in 2007 to that in 2011?
Offer a terse response. 1.21. What is the ratio of the Rent(as % of GDP) of Central African Republic in 2007 to that in 2011?
Provide a succinct answer. 0.04. What is the ratio of the Rent(as % of GDP) of Ecuador in 2007 to that in 2011?
Make the answer very short. 0.62. What is the ratio of the Rent(as % of GDP) of Lao PDR in 2007 to that in 2011?
Offer a very short reply. 0.69. What is the ratio of the Rent(as % of GDP) in Brazil in 2008 to that in 2009?
Your answer should be very brief. 2.29. What is the ratio of the Rent(as % of GDP) in Central African Republic in 2008 to that in 2009?
Your answer should be compact. 0.56. What is the ratio of the Rent(as % of GDP) in Ecuador in 2008 to that in 2009?
Provide a short and direct response. 0.29. What is the ratio of the Rent(as % of GDP) of Lao PDR in 2008 to that in 2009?
Provide a succinct answer. 1.08. What is the ratio of the Rent(as % of GDP) of Brazil in 2008 to that in 2010?
Make the answer very short. 1.31. What is the ratio of the Rent(as % of GDP) of Central African Republic in 2008 to that in 2010?
Ensure brevity in your answer.  0.41. What is the ratio of the Rent(as % of GDP) in Ecuador in 2008 to that in 2010?
Your response must be concise. 0.24. What is the ratio of the Rent(as % of GDP) in Lao PDR in 2008 to that in 2010?
Your answer should be compact. 0.77. What is the ratio of the Rent(as % of GDP) in Brazil in 2008 to that in 2011?
Keep it short and to the point. 1.25. What is the ratio of the Rent(as % of GDP) of Central African Republic in 2008 to that in 2011?
Keep it short and to the point. 0.2. What is the ratio of the Rent(as % of GDP) in Ecuador in 2008 to that in 2011?
Your answer should be very brief. 0.2. What is the ratio of the Rent(as % of GDP) of Lao PDR in 2008 to that in 2011?
Provide a short and direct response. 0.7. What is the ratio of the Rent(as % of GDP) of Brazil in 2009 to that in 2010?
Give a very brief answer. 0.57. What is the ratio of the Rent(as % of GDP) in Central African Republic in 2009 to that in 2010?
Ensure brevity in your answer.  0.73. What is the ratio of the Rent(as % of GDP) of Ecuador in 2009 to that in 2010?
Make the answer very short. 0.81. What is the ratio of the Rent(as % of GDP) in Lao PDR in 2009 to that in 2010?
Your response must be concise. 0.71. What is the ratio of the Rent(as % of GDP) in Brazil in 2009 to that in 2011?
Give a very brief answer. 0.55. What is the ratio of the Rent(as % of GDP) of Central African Republic in 2009 to that in 2011?
Your answer should be very brief. 0.35. What is the ratio of the Rent(as % of GDP) in Ecuador in 2009 to that in 2011?
Your response must be concise. 0.66. What is the ratio of the Rent(as % of GDP) in Lao PDR in 2009 to that in 2011?
Your response must be concise. 0.65. What is the ratio of the Rent(as % of GDP) of Brazil in 2010 to that in 2011?
Keep it short and to the point. 0.96. What is the ratio of the Rent(as % of GDP) in Central African Republic in 2010 to that in 2011?
Your answer should be very brief. 0.48. What is the ratio of the Rent(as % of GDP) of Ecuador in 2010 to that in 2011?
Provide a succinct answer. 0.82. What is the ratio of the Rent(as % of GDP) of Lao PDR in 2010 to that in 2011?
Make the answer very short. 0.91. What is the difference between the highest and the second highest Rent(as % of GDP) in Brazil?
Provide a succinct answer. 0.13. What is the difference between the highest and the second highest Rent(as % of GDP) in Central African Republic?
Your answer should be compact. 0.09. What is the difference between the highest and the second highest Rent(as % of GDP) of Ecuador?
Keep it short and to the point. 0.02. What is the difference between the highest and the second highest Rent(as % of GDP) of Lao PDR?
Provide a short and direct response. 1.34. What is the difference between the highest and the lowest Rent(as % of GDP) of Brazil?
Your response must be concise. 1.88. What is the difference between the highest and the lowest Rent(as % of GDP) of Central African Republic?
Your answer should be compact. 0.16. What is the difference between the highest and the lowest Rent(as % of GDP) in Ecuador?
Keep it short and to the point. 0.07. What is the difference between the highest and the lowest Rent(as % of GDP) of Lao PDR?
Keep it short and to the point. 5.06. 